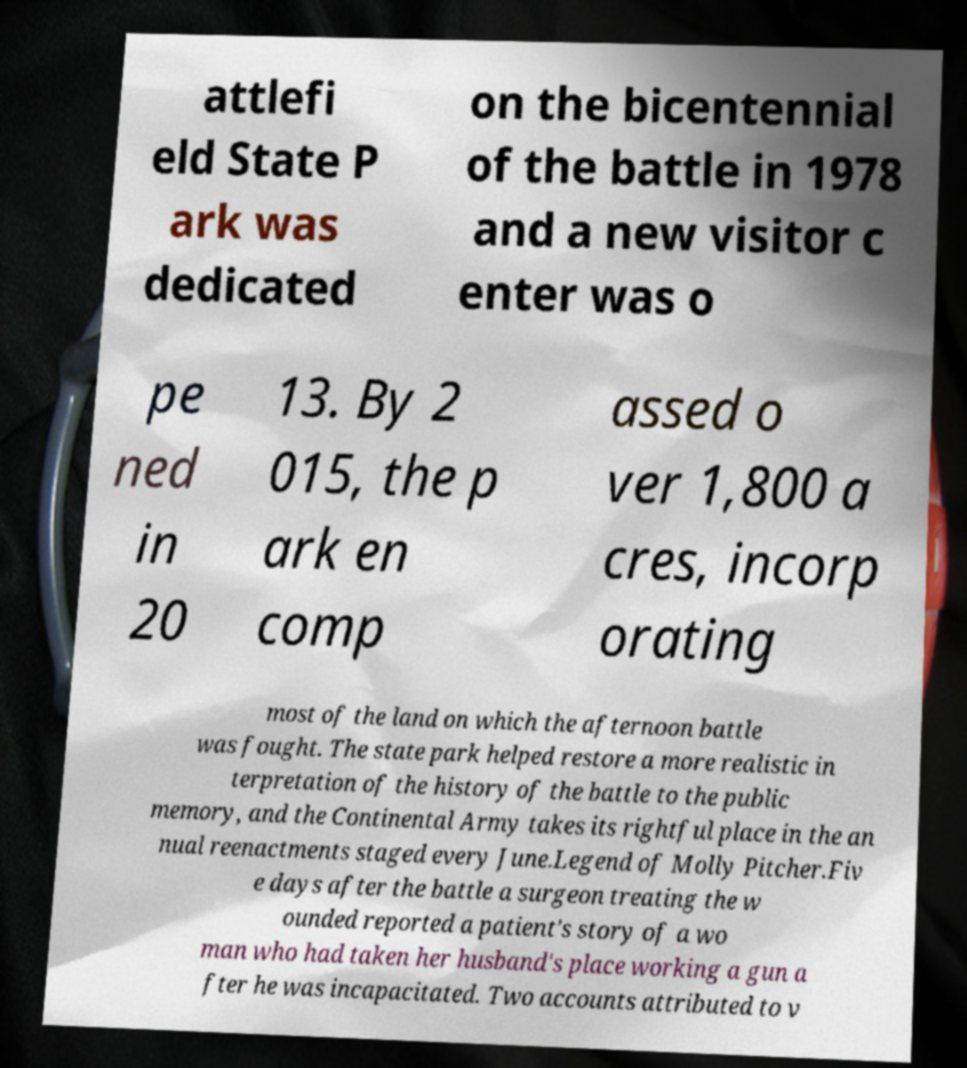Can you read and provide the text displayed in the image?This photo seems to have some interesting text. Can you extract and type it out for me? attlefi eld State P ark was dedicated on the bicentennial of the battle in 1978 and a new visitor c enter was o pe ned in 20 13. By 2 015, the p ark en comp assed o ver 1,800 a cres, incorp orating most of the land on which the afternoon battle was fought. The state park helped restore a more realistic in terpretation of the history of the battle to the public memory, and the Continental Army takes its rightful place in the an nual reenactments staged every June.Legend of Molly Pitcher.Fiv e days after the battle a surgeon treating the w ounded reported a patient's story of a wo man who had taken her husband's place working a gun a fter he was incapacitated. Two accounts attributed to v 